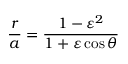Convert formula to latex. <formula><loc_0><loc_0><loc_500><loc_500>{ \frac { r } { a } } = { \frac { 1 - \varepsilon ^ { 2 } } { 1 + \varepsilon \cos \theta } }</formula> 